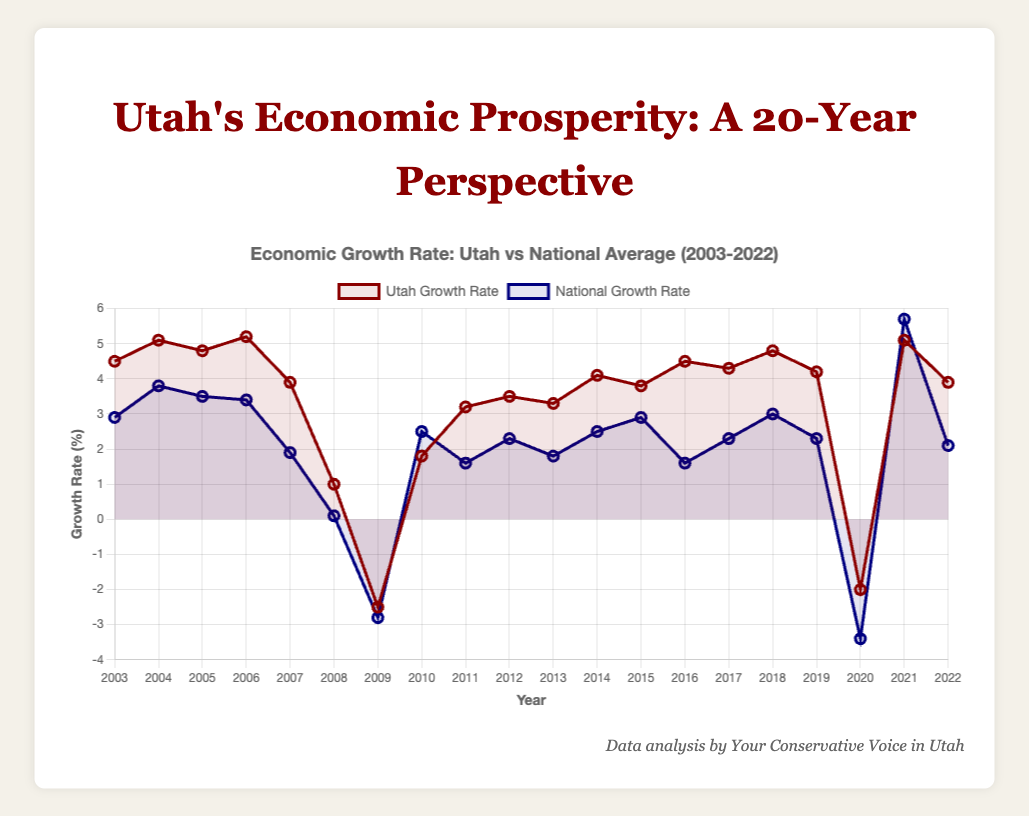what years did Utah experience an economic growth rate decline? Reviewing the Utah growth rate data, we observe negative values in the years 2009 and 2020.
Answer: 2009 and 2020 Which year had the highest economic growth rate for both Utah and the national average? Observing the peak points on the chart, the highest Utah growth rate is in 2006 with 5.2%, and for the national average, it is in 2021 with 5.7%.
Answer: 2006 (Utah) and 2021 (national average) On average, which had a higher growth rate over the 20-year period, Utah or the national average? To find the average, sum all the growth rates for each and divide by the number of years (20). Utah's sum is 70.6 and the national average’s sum is 41.2, resulting in averages of 3.53% and 2.06%, respectively.
Answer: Utah What is the difference between Utah’s and the national average growth rates in 2021? Utah's growth rate in 2021 is 5.1%, and the national average is 5.7%. The difference is 5.7% - 5.1% = 0.6%.
Answer: 0.6% How many times did the national average growth rate exceed Utah’s over the 20 years? Comparing year by year, the national average exceeded Utah's in 2008, 2009, 2010, 2013, 2015, 2016, 2020, and 2021, totaling 8 instances.
Answer: 8 What visual attributes differentiate Utah's growth rate line from the national average's line? Utah’s growth rate line is depicted in dark red color, whereas the national average’s line is dark blue. Additionally, the point markers and hover effects follow these color distinctions.
Answer: color and markers In which consecutive years did Utah experience its highest sustained growth? The highest consecutive growth periods occur from 2004 to 2006, and 2017 to 2019, analyzing the yearly data shows this.
Answer: 2004 to 2006 and 2017 to 2019 Between 2014 and 2018, which year recorded the lowest growth rate for Utah and how does it compare to the national average of that year? Within 2014 and 2018, Utah’s lowest growth year is 2014 (3.8%), while the national average for that year is 2.5%. 3.8% is higher than 2.5%.
Answer: 2014, Utah higher Determine the median growth rate for Utah across the 20 years. Sorting Utah’s growth rates and finding the middle value, the median is the average of the 10th and 11th values (3.5% and 3.8%), resulting in (3.5 + 3.8)/2 = 3.65%.
Answer: 3.65% In which year did the national average growth rate rebound from its lowest point, and how does Utah’s rate that year compare? The national average bottomed at -3.4% in 2020 and rebounded to 5.7% in 2021. Utah’s growth rate in 2021 was 5.1%, which is lower than the national average that year.
Answer: 2021, Utah lower 